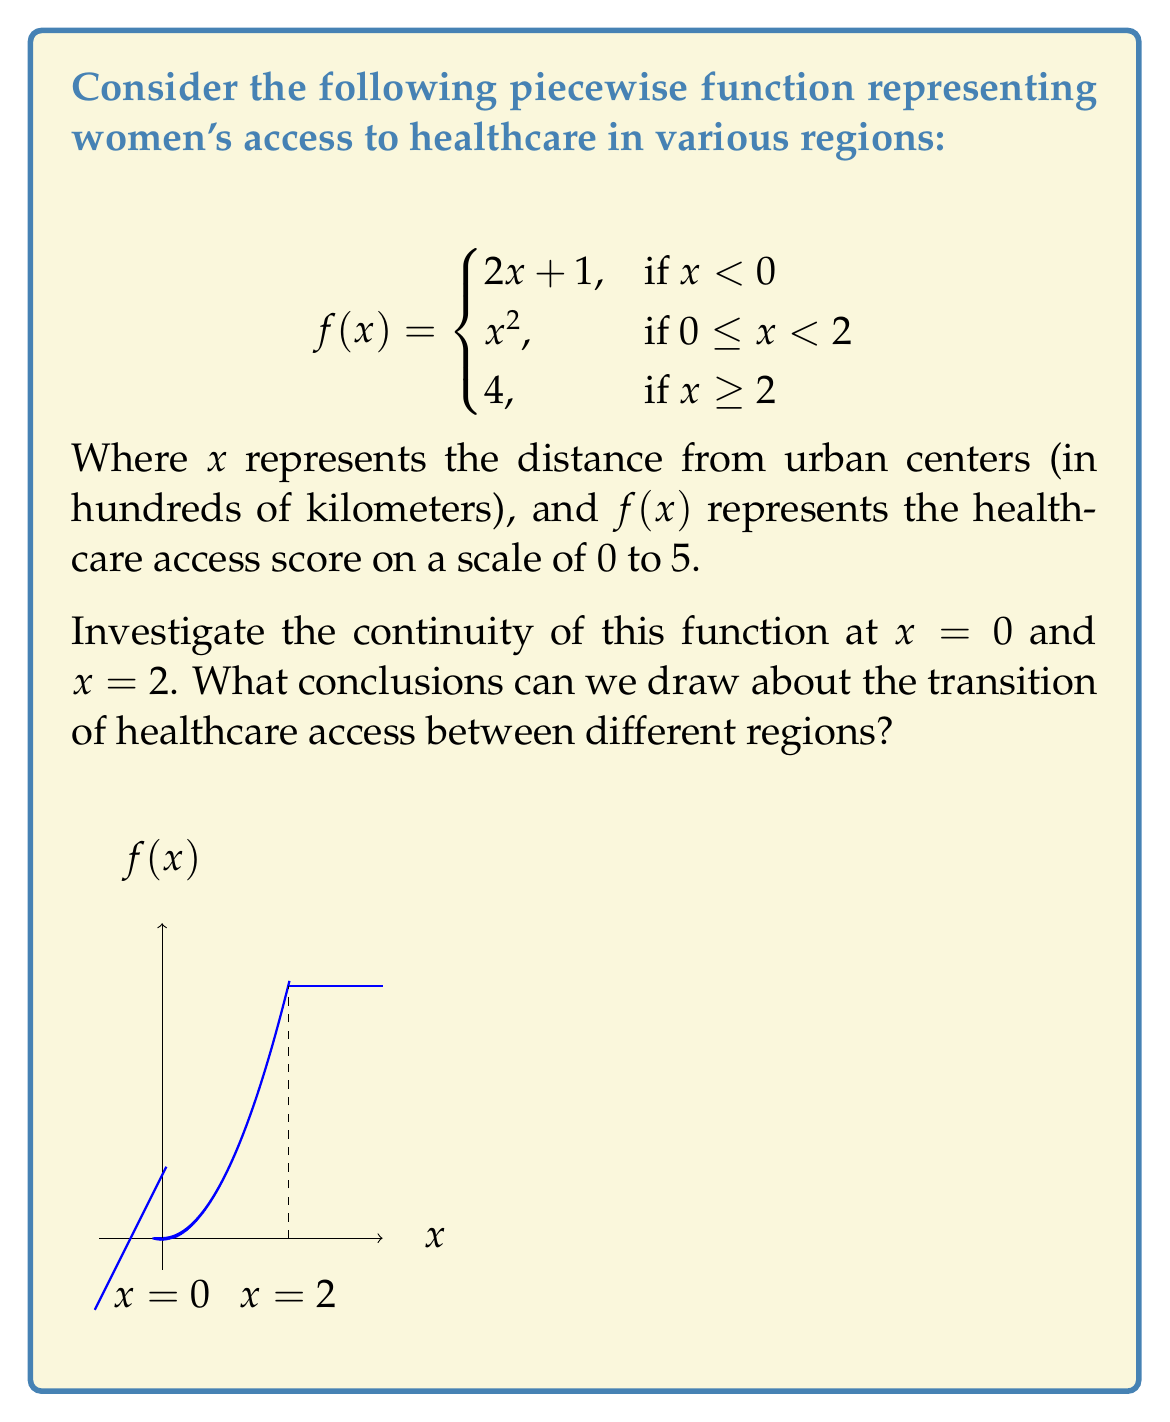Help me with this question. To investigate the continuity of the function at $x = 0$ and $x = 2$, we need to check if the function satisfies the three conditions for continuity at these points:

1. The function is defined at the point.
2. The limit of the function as we approach the point from both sides exists.
3. The limit is equal to the function value at that point.

For $x = 0$:

1. $f(0)$ is defined: $f(0) = 0^2 = 0$
2. Left-hand limit: 
   $\lim_{x \to 0^-} f(x) = \lim_{x \to 0^-} (2x + 1) = 1$
   Right-hand limit:
   $\lim_{x \to 0^+} f(x) = \lim_{x \to 0^+} x^2 = 0$
3. The left-hand limit $\neq$ right-hand limit $\neq f(0)$

Therefore, $f(x)$ is not continuous at $x = 0$.

For $x = 2$:

1. $f(2)$ is defined: $f(2) = 4$
2. Left-hand limit:
   $\lim_{x \to 2^-} f(x) = \lim_{x \to 2^-} x^2 = 4$
   Right-hand limit:
   $\lim_{x \to 2^+} f(x) = 4$
3. Both limits equal $f(2) = 4$

Therefore, $f(x)$ is continuous at $x = 2$.

Conclusions about healthcare access:
1. There is a sudden jump in healthcare access when moving from rural to urban areas (at $x = 0$), indicating a significant disparity.
2. Healthcare access improves smoothly as we move closer to urban centers (0 ≤ x < 2).
3. There is a smooth transition to maximum healthcare access at x = 2, after which it remains constant.
Answer: $f(x)$ is discontinuous at $x = 0$ and continuous at $x = 2$, revealing an abrupt change in healthcare access between rural and urban areas, followed by a smooth improvement towards urban centers. 